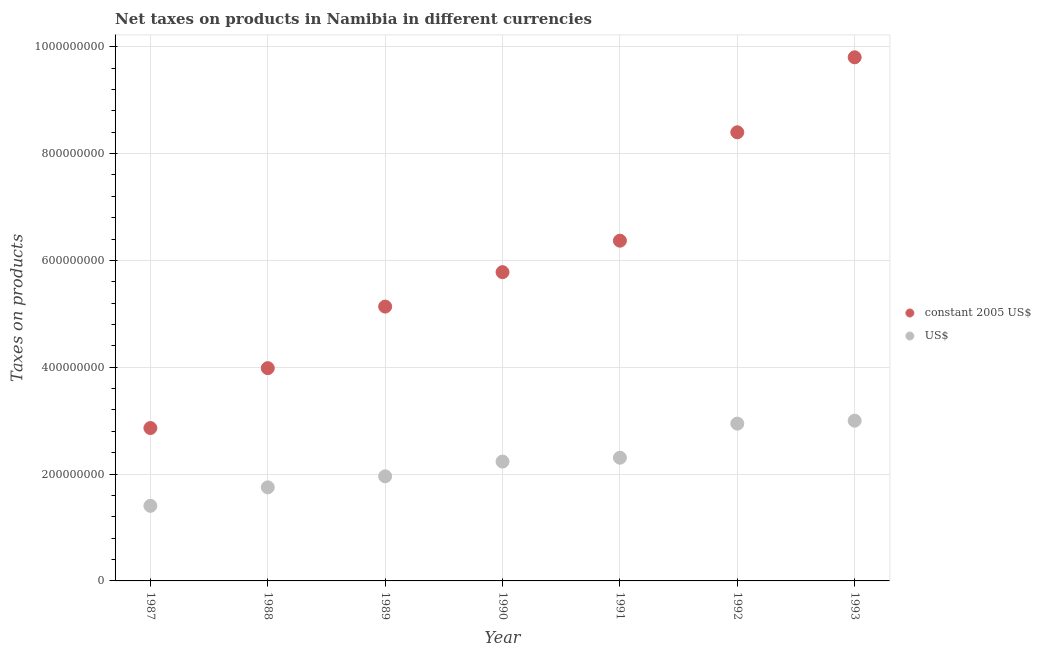How many different coloured dotlines are there?
Ensure brevity in your answer.  2. Is the number of dotlines equal to the number of legend labels?
Give a very brief answer. Yes. What is the net taxes in us$ in 1992?
Your answer should be very brief. 2.94e+08. Across all years, what is the maximum net taxes in constant 2005 us$?
Keep it short and to the point. 9.80e+08. Across all years, what is the minimum net taxes in constant 2005 us$?
Your response must be concise. 2.86e+08. In which year was the net taxes in us$ maximum?
Your response must be concise. 1993. In which year was the net taxes in us$ minimum?
Keep it short and to the point. 1987. What is the total net taxes in constant 2005 us$ in the graph?
Offer a terse response. 4.23e+09. What is the difference between the net taxes in constant 2005 us$ in 1992 and that in 1993?
Your response must be concise. -1.40e+08. What is the difference between the net taxes in constant 2005 us$ in 1989 and the net taxes in us$ in 1993?
Keep it short and to the point. 2.14e+08. What is the average net taxes in constant 2005 us$ per year?
Offer a very short reply. 6.05e+08. In the year 1988, what is the difference between the net taxes in us$ and net taxes in constant 2005 us$?
Ensure brevity in your answer.  -2.23e+08. In how many years, is the net taxes in us$ greater than 80000000 units?
Ensure brevity in your answer.  7. What is the ratio of the net taxes in constant 2005 us$ in 1990 to that in 1991?
Your answer should be very brief. 0.91. Is the net taxes in us$ in 1988 less than that in 1990?
Offer a terse response. Yes. Is the difference between the net taxes in us$ in 1989 and 1991 greater than the difference between the net taxes in constant 2005 us$ in 1989 and 1991?
Offer a very short reply. Yes. What is the difference between the highest and the second highest net taxes in constant 2005 us$?
Offer a terse response. 1.40e+08. What is the difference between the highest and the lowest net taxes in constant 2005 us$?
Your answer should be very brief. 6.94e+08. In how many years, is the net taxes in us$ greater than the average net taxes in us$ taken over all years?
Provide a short and direct response. 4. Does the net taxes in us$ monotonically increase over the years?
Your answer should be very brief. Yes. How many dotlines are there?
Offer a very short reply. 2. Are the values on the major ticks of Y-axis written in scientific E-notation?
Provide a succinct answer. No. Does the graph contain any zero values?
Keep it short and to the point. No. How are the legend labels stacked?
Provide a short and direct response. Vertical. What is the title of the graph?
Provide a succinct answer. Net taxes on products in Namibia in different currencies. What is the label or title of the Y-axis?
Offer a very short reply. Taxes on products. What is the Taxes on products in constant 2005 US$ in 1987?
Provide a succinct answer. 2.86e+08. What is the Taxes on products in US$ in 1987?
Provide a succinct answer. 1.41e+08. What is the Taxes on products of constant 2005 US$ in 1988?
Your answer should be compact. 3.98e+08. What is the Taxes on products in US$ in 1988?
Your answer should be very brief. 1.75e+08. What is the Taxes on products of constant 2005 US$ in 1989?
Offer a terse response. 5.14e+08. What is the Taxes on products in US$ in 1989?
Make the answer very short. 1.96e+08. What is the Taxes on products of constant 2005 US$ in 1990?
Provide a succinct answer. 5.78e+08. What is the Taxes on products in US$ in 1990?
Provide a succinct answer. 2.23e+08. What is the Taxes on products in constant 2005 US$ in 1991?
Ensure brevity in your answer.  6.37e+08. What is the Taxes on products in US$ in 1991?
Keep it short and to the point. 2.31e+08. What is the Taxes on products of constant 2005 US$ in 1992?
Keep it short and to the point. 8.40e+08. What is the Taxes on products of US$ in 1992?
Ensure brevity in your answer.  2.94e+08. What is the Taxes on products of constant 2005 US$ in 1993?
Keep it short and to the point. 9.80e+08. What is the Taxes on products of US$ in 1993?
Your answer should be compact. 3.00e+08. Across all years, what is the maximum Taxes on products in constant 2005 US$?
Provide a succinct answer. 9.80e+08. Across all years, what is the maximum Taxes on products in US$?
Keep it short and to the point. 3.00e+08. Across all years, what is the minimum Taxes on products of constant 2005 US$?
Your response must be concise. 2.86e+08. Across all years, what is the minimum Taxes on products in US$?
Your answer should be very brief. 1.41e+08. What is the total Taxes on products in constant 2005 US$ in the graph?
Provide a short and direct response. 4.23e+09. What is the total Taxes on products of US$ in the graph?
Your answer should be very brief. 1.56e+09. What is the difference between the Taxes on products in constant 2005 US$ in 1987 and that in 1988?
Your answer should be compact. -1.12e+08. What is the difference between the Taxes on products of US$ in 1987 and that in 1988?
Give a very brief answer. -3.46e+07. What is the difference between the Taxes on products in constant 2005 US$ in 1987 and that in 1989?
Keep it short and to the point. -2.27e+08. What is the difference between the Taxes on products in US$ in 1987 and that in 1989?
Offer a very short reply. -5.52e+07. What is the difference between the Taxes on products in constant 2005 US$ in 1987 and that in 1990?
Your response must be concise. -2.92e+08. What is the difference between the Taxes on products in US$ in 1987 and that in 1990?
Make the answer very short. -8.28e+07. What is the difference between the Taxes on products of constant 2005 US$ in 1987 and that in 1991?
Ensure brevity in your answer.  -3.51e+08. What is the difference between the Taxes on products of US$ in 1987 and that in 1991?
Offer a terse response. -9.01e+07. What is the difference between the Taxes on products in constant 2005 US$ in 1987 and that in 1992?
Keep it short and to the point. -5.54e+08. What is the difference between the Taxes on products of US$ in 1987 and that in 1992?
Ensure brevity in your answer.  -1.54e+08. What is the difference between the Taxes on products of constant 2005 US$ in 1987 and that in 1993?
Give a very brief answer. -6.94e+08. What is the difference between the Taxes on products in US$ in 1987 and that in 1993?
Provide a succinct answer. -1.59e+08. What is the difference between the Taxes on products of constant 2005 US$ in 1988 and that in 1989?
Your answer should be compact. -1.15e+08. What is the difference between the Taxes on products in US$ in 1988 and that in 1989?
Give a very brief answer. -2.06e+07. What is the difference between the Taxes on products of constant 2005 US$ in 1988 and that in 1990?
Your answer should be compact. -1.80e+08. What is the difference between the Taxes on products in US$ in 1988 and that in 1990?
Provide a succinct answer. -4.82e+07. What is the difference between the Taxes on products of constant 2005 US$ in 1988 and that in 1991?
Your answer should be compact. -2.39e+08. What is the difference between the Taxes on products of US$ in 1988 and that in 1991?
Provide a short and direct response. -5.55e+07. What is the difference between the Taxes on products of constant 2005 US$ in 1988 and that in 1992?
Your answer should be compact. -4.42e+08. What is the difference between the Taxes on products of US$ in 1988 and that in 1992?
Offer a terse response. -1.19e+08. What is the difference between the Taxes on products of constant 2005 US$ in 1988 and that in 1993?
Your answer should be compact. -5.82e+08. What is the difference between the Taxes on products in US$ in 1988 and that in 1993?
Your answer should be very brief. -1.25e+08. What is the difference between the Taxes on products of constant 2005 US$ in 1989 and that in 1990?
Offer a terse response. -6.45e+07. What is the difference between the Taxes on products in US$ in 1989 and that in 1990?
Provide a short and direct response. -2.76e+07. What is the difference between the Taxes on products of constant 2005 US$ in 1989 and that in 1991?
Your answer should be compact. -1.23e+08. What is the difference between the Taxes on products in US$ in 1989 and that in 1991?
Your answer should be very brief. -3.48e+07. What is the difference between the Taxes on products of constant 2005 US$ in 1989 and that in 1992?
Provide a short and direct response. -3.26e+08. What is the difference between the Taxes on products of US$ in 1989 and that in 1992?
Offer a very short reply. -9.87e+07. What is the difference between the Taxes on products of constant 2005 US$ in 1989 and that in 1993?
Offer a terse response. -4.67e+08. What is the difference between the Taxes on products of US$ in 1989 and that in 1993?
Make the answer very short. -1.04e+08. What is the difference between the Taxes on products in constant 2005 US$ in 1990 and that in 1991?
Your answer should be very brief. -5.89e+07. What is the difference between the Taxes on products of US$ in 1990 and that in 1991?
Provide a succinct answer. -7.26e+06. What is the difference between the Taxes on products in constant 2005 US$ in 1990 and that in 1992?
Your answer should be very brief. -2.62e+08. What is the difference between the Taxes on products of US$ in 1990 and that in 1992?
Your response must be concise. -7.11e+07. What is the difference between the Taxes on products of constant 2005 US$ in 1990 and that in 1993?
Your answer should be very brief. -4.02e+08. What is the difference between the Taxes on products in US$ in 1990 and that in 1993?
Provide a short and direct response. -7.66e+07. What is the difference between the Taxes on products in constant 2005 US$ in 1991 and that in 1992?
Keep it short and to the point. -2.03e+08. What is the difference between the Taxes on products of US$ in 1991 and that in 1992?
Offer a very short reply. -6.38e+07. What is the difference between the Taxes on products in constant 2005 US$ in 1991 and that in 1993?
Your answer should be very brief. -3.43e+08. What is the difference between the Taxes on products of US$ in 1991 and that in 1993?
Give a very brief answer. -6.93e+07. What is the difference between the Taxes on products of constant 2005 US$ in 1992 and that in 1993?
Offer a very short reply. -1.40e+08. What is the difference between the Taxes on products of US$ in 1992 and that in 1993?
Give a very brief answer. -5.50e+06. What is the difference between the Taxes on products in constant 2005 US$ in 1987 and the Taxes on products in US$ in 1988?
Your response must be concise. 1.11e+08. What is the difference between the Taxes on products in constant 2005 US$ in 1987 and the Taxes on products in US$ in 1989?
Your answer should be compact. 9.04e+07. What is the difference between the Taxes on products in constant 2005 US$ in 1987 and the Taxes on products in US$ in 1990?
Provide a short and direct response. 6.28e+07. What is the difference between the Taxes on products of constant 2005 US$ in 1987 and the Taxes on products of US$ in 1991?
Make the answer very short. 5.55e+07. What is the difference between the Taxes on products in constant 2005 US$ in 1987 and the Taxes on products in US$ in 1992?
Give a very brief answer. -8.26e+06. What is the difference between the Taxes on products in constant 2005 US$ in 1987 and the Taxes on products in US$ in 1993?
Keep it short and to the point. -1.38e+07. What is the difference between the Taxes on products in constant 2005 US$ in 1988 and the Taxes on products in US$ in 1989?
Offer a terse response. 2.03e+08. What is the difference between the Taxes on products of constant 2005 US$ in 1988 and the Taxes on products of US$ in 1990?
Give a very brief answer. 1.75e+08. What is the difference between the Taxes on products in constant 2005 US$ in 1988 and the Taxes on products in US$ in 1991?
Your response must be concise. 1.68e+08. What is the difference between the Taxes on products of constant 2005 US$ in 1988 and the Taxes on products of US$ in 1992?
Keep it short and to the point. 1.04e+08. What is the difference between the Taxes on products of constant 2005 US$ in 1988 and the Taxes on products of US$ in 1993?
Offer a terse response. 9.83e+07. What is the difference between the Taxes on products of constant 2005 US$ in 1989 and the Taxes on products of US$ in 1990?
Ensure brevity in your answer.  2.90e+08. What is the difference between the Taxes on products of constant 2005 US$ in 1989 and the Taxes on products of US$ in 1991?
Offer a terse response. 2.83e+08. What is the difference between the Taxes on products of constant 2005 US$ in 1989 and the Taxes on products of US$ in 1992?
Make the answer very short. 2.19e+08. What is the difference between the Taxes on products in constant 2005 US$ in 1989 and the Taxes on products in US$ in 1993?
Offer a terse response. 2.14e+08. What is the difference between the Taxes on products of constant 2005 US$ in 1990 and the Taxes on products of US$ in 1991?
Your answer should be compact. 3.47e+08. What is the difference between the Taxes on products in constant 2005 US$ in 1990 and the Taxes on products in US$ in 1992?
Offer a very short reply. 2.84e+08. What is the difference between the Taxes on products in constant 2005 US$ in 1990 and the Taxes on products in US$ in 1993?
Give a very brief answer. 2.78e+08. What is the difference between the Taxes on products of constant 2005 US$ in 1991 and the Taxes on products of US$ in 1992?
Provide a succinct answer. 3.42e+08. What is the difference between the Taxes on products in constant 2005 US$ in 1991 and the Taxes on products in US$ in 1993?
Offer a very short reply. 3.37e+08. What is the difference between the Taxes on products in constant 2005 US$ in 1992 and the Taxes on products in US$ in 1993?
Offer a terse response. 5.40e+08. What is the average Taxes on products in constant 2005 US$ per year?
Provide a short and direct response. 6.05e+08. What is the average Taxes on products of US$ per year?
Give a very brief answer. 2.23e+08. In the year 1987, what is the difference between the Taxes on products in constant 2005 US$ and Taxes on products in US$?
Offer a terse response. 1.46e+08. In the year 1988, what is the difference between the Taxes on products in constant 2005 US$ and Taxes on products in US$?
Ensure brevity in your answer.  2.23e+08. In the year 1989, what is the difference between the Taxes on products in constant 2005 US$ and Taxes on products in US$?
Your answer should be compact. 3.18e+08. In the year 1990, what is the difference between the Taxes on products of constant 2005 US$ and Taxes on products of US$?
Make the answer very short. 3.55e+08. In the year 1991, what is the difference between the Taxes on products in constant 2005 US$ and Taxes on products in US$?
Your answer should be compact. 4.06e+08. In the year 1992, what is the difference between the Taxes on products of constant 2005 US$ and Taxes on products of US$?
Ensure brevity in your answer.  5.45e+08. In the year 1993, what is the difference between the Taxes on products in constant 2005 US$ and Taxes on products in US$?
Your answer should be very brief. 6.80e+08. What is the ratio of the Taxes on products in constant 2005 US$ in 1987 to that in 1988?
Offer a terse response. 0.72. What is the ratio of the Taxes on products of US$ in 1987 to that in 1988?
Ensure brevity in your answer.  0.8. What is the ratio of the Taxes on products of constant 2005 US$ in 1987 to that in 1989?
Your answer should be very brief. 0.56. What is the ratio of the Taxes on products in US$ in 1987 to that in 1989?
Provide a succinct answer. 0.72. What is the ratio of the Taxes on products of constant 2005 US$ in 1987 to that in 1990?
Give a very brief answer. 0.5. What is the ratio of the Taxes on products of US$ in 1987 to that in 1990?
Your answer should be compact. 0.63. What is the ratio of the Taxes on products of constant 2005 US$ in 1987 to that in 1991?
Provide a succinct answer. 0.45. What is the ratio of the Taxes on products in US$ in 1987 to that in 1991?
Keep it short and to the point. 0.61. What is the ratio of the Taxes on products of constant 2005 US$ in 1987 to that in 1992?
Your answer should be compact. 0.34. What is the ratio of the Taxes on products in US$ in 1987 to that in 1992?
Your answer should be very brief. 0.48. What is the ratio of the Taxes on products of constant 2005 US$ in 1987 to that in 1993?
Your answer should be compact. 0.29. What is the ratio of the Taxes on products of US$ in 1987 to that in 1993?
Your response must be concise. 0.47. What is the ratio of the Taxes on products of constant 2005 US$ in 1988 to that in 1989?
Ensure brevity in your answer.  0.78. What is the ratio of the Taxes on products of US$ in 1988 to that in 1989?
Provide a short and direct response. 0.89. What is the ratio of the Taxes on products of constant 2005 US$ in 1988 to that in 1990?
Provide a short and direct response. 0.69. What is the ratio of the Taxes on products in US$ in 1988 to that in 1990?
Keep it short and to the point. 0.78. What is the ratio of the Taxes on products in constant 2005 US$ in 1988 to that in 1991?
Give a very brief answer. 0.63. What is the ratio of the Taxes on products in US$ in 1988 to that in 1991?
Your answer should be very brief. 0.76. What is the ratio of the Taxes on products of constant 2005 US$ in 1988 to that in 1992?
Your answer should be compact. 0.47. What is the ratio of the Taxes on products of US$ in 1988 to that in 1992?
Make the answer very short. 0.59. What is the ratio of the Taxes on products of constant 2005 US$ in 1988 to that in 1993?
Ensure brevity in your answer.  0.41. What is the ratio of the Taxes on products in US$ in 1988 to that in 1993?
Keep it short and to the point. 0.58. What is the ratio of the Taxes on products in constant 2005 US$ in 1989 to that in 1990?
Provide a succinct answer. 0.89. What is the ratio of the Taxes on products in US$ in 1989 to that in 1990?
Your answer should be very brief. 0.88. What is the ratio of the Taxes on products of constant 2005 US$ in 1989 to that in 1991?
Ensure brevity in your answer.  0.81. What is the ratio of the Taxes on products of US$ in 1989 to that in 1991?
Offer a very short reply. 0.85. What is the ratio of the Taxes on products of constant 2005 US$ in 1989 to that in 1992?
Make the answer very short. 0.61. What is the ratio of the Taxes on products in US$ in 1989 to that in 1992?
Your answer should be very brief. 0.67. What is the ratio of the Taxes on products in constant 2005 US$ in 1989 to that in 1993?
Provide a short and direct response. 0.52. What is the ratio of the Taxes on products of US$ in 1989 to that in 1993?
Provide a short and direct response. 0.65. What is the ratio of the Taxes on products in constant 2005 US$ in 1990 to that in 1991?
Your response must be concise. 0.91. What is the ratio of the Taxes on products of US$ in 1990 to that in 1991?
Make the answer very short. 0.97. What is the ratio of the Taxes on products in constant 2005 US$ in 1990 to that in 1992?
Your response must be concise. 0.69. What is the ratio of the Taxes on products in US$ in 1990 to that in 1992?
Offer a terse response. 0.76. What is the ratio of the Taxes on products in constant 2005 US$ in 1990 to that in 1993?
Make the answer very short. 0.59. What is the ratio of the Taxes on products of US$ in 1990 to that in 1993?
Provide a short and direct response. 0.74. What is the ratio of the Taxes on products in constant 2005 US$ in 1991 to that in 1992?
Give a very brief answer. 0.76. What is the ratio of the Taxes on products in US$ in 1991 to that in 1992?
Your answer should be very brief. 0.78. What is the ratio of the Taxes on products in constant 2005 US$ in 1991 to that in 1993?
Your answer should be compact. 0.65. What is the ratio of the Taxes on products of US$ in 1991 to that in 1993?
Provide a short and direct response. 0.77. What is the ratio of the Taxes on products in constant 2005 US$ in 1992 to that in 1993?
Offer a very short reply. 0.86. What is the ratio of the Taxes on products in US$ in 1992 to that in 1993?
Ensure brevity in your answer.  0.98. What is the difference between the highest and the second highest Taxes on products of constant 2005 US$?
Offer a terse response. 1.40e+08. What is the difference between the highest and the second highest Taxes on products of US$?
Make the answer very short. 5.50e+06. What is the difference between the highest and the lowest Taxes on products in constant 2005 US$?
Your response must be concise. 6.94e+08. What is the difference between the highest and the lowest Taxes on products in US$?
Keep it short and to the point. 1.59e+08. 